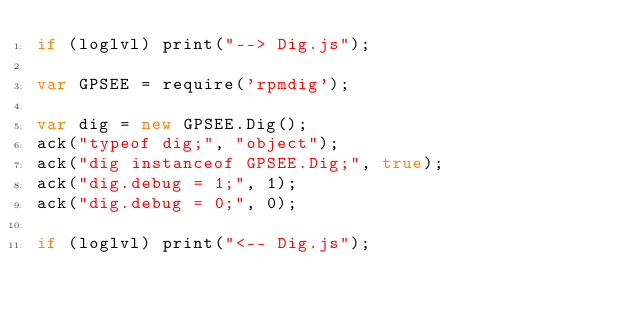Convert code to text. <code><loc_0><loc_0><loc_500><loc_500><_JavaScript_>if (loglvl) print("--> Dig.js");

var GPSEE = require('rpmdig');

var dig = new GPSEE.Dig();
ack("typeof dig;", "object");
ack("dig instanceof GPSEE.Dig;", true);
ack("dig.debug = 1;", 1);
ack("dig.debug = 0;", 0);

if (loglvl) print("<-- Dig.js");
</code> 